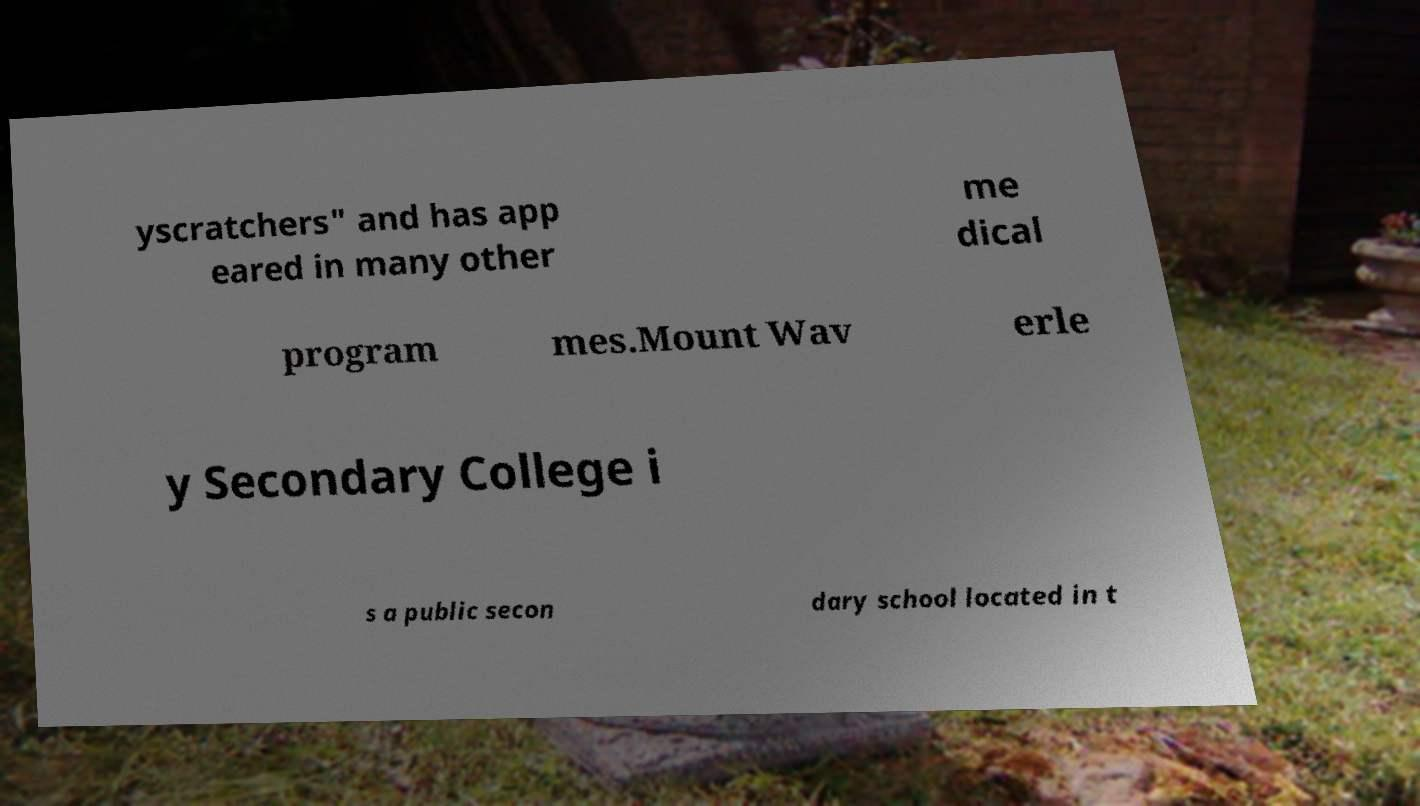I need the written content from this picture converted into text. Can you do that? yscratchers" and has app eared in many other me dical program mes.Mount Wav erle y Secondary College i s a public secon dary school located in t 